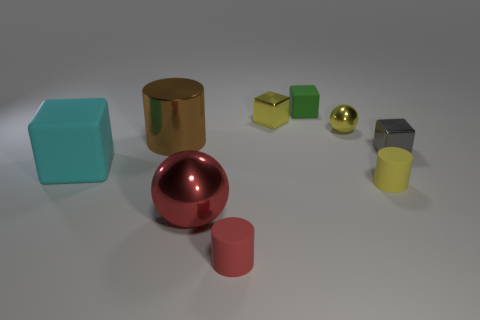Are there the same number of gray blocks behind the tiny gray shiny block and tiny red matte blocks?
Provide a succinct answer. Yes. What color is the large rubber thing?
Your answer should be very brief. Cyan. What size is the red sphere that is made of the same material as the large cylinder?
Your answer should be very brief. Large. There is a small cube that is made of the same material as the tiny gray thing; what is its color?
Offer a terse response. Yellow. Are there any yellow rubber cylinders that have the same size as the cyan rubber object?
Provide a succinct answer. No. What is the material of the red thing that is the same shape as the brown object?
Provide a short and direct response. Rubber. The red thing that is the same size as the cyan matte object is what shape?
Your answer should be very brief. Sphere. Are there any small green objects that have the same shape as the cyan matte object?
Your answer should be very brief. Yes. What shape is the yellow thing in front of the rubber block that is left of the tiny matte block?
Your answer should be very brief. Cylinder. What is the shape of the small red rubber thing?
Provide a short and direct response. Cylinder. 